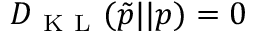<formula> <loc_0><loc_0><loc_500><loc_500>D _ { K L } ( \tilde { p } | | p ) = 0</formula> 